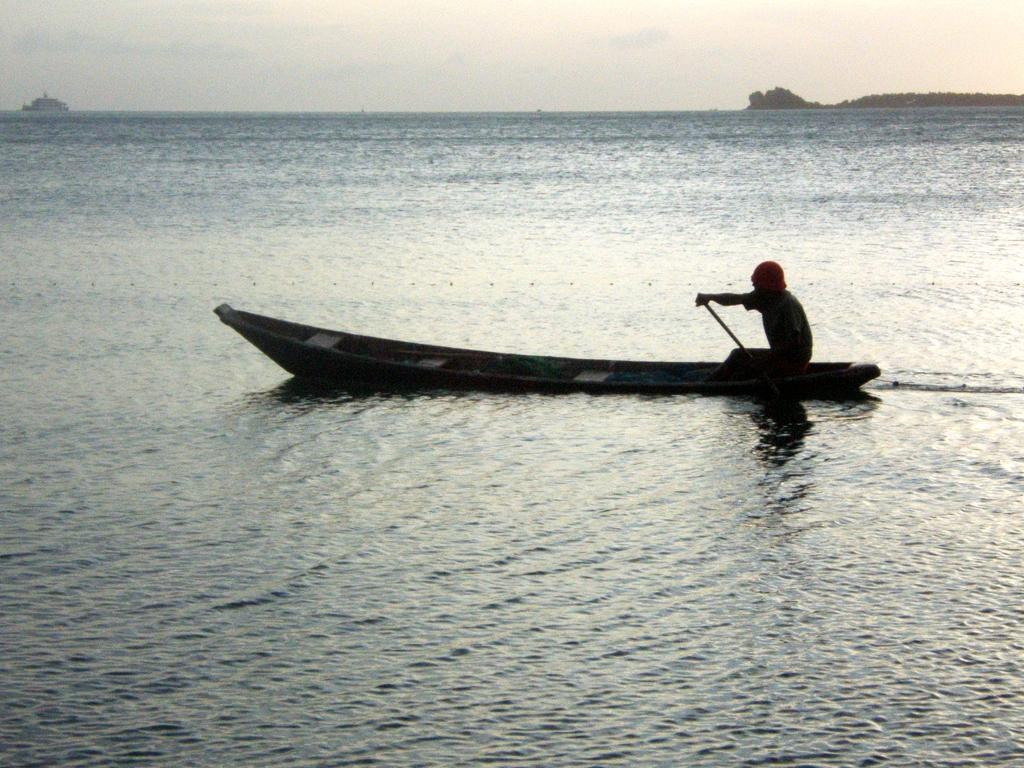What is the person in the image doing? There is a person sitting on a boat in the image. Where is the boat located? The boat is on the water in the image. What type of water body is the boat on? The water is part of an ocean. What can be seen in the background of the image? There is a ship and a mountain in the background, as well as clouds in the sky. What type of meat is being cooked on the boat in the image? There is no meat or cooking activity visible in the image; it only shows a person sitting on a boat in an ocean with a ship and a mountain in the background. 